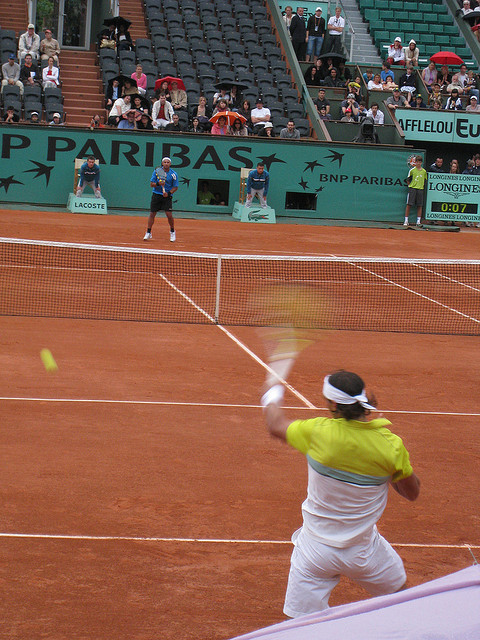Read and extract the text from this image. PARIBAS AFFLELOU BNP PARIBA LONGINE Eu 0:07 LACOSTE P 